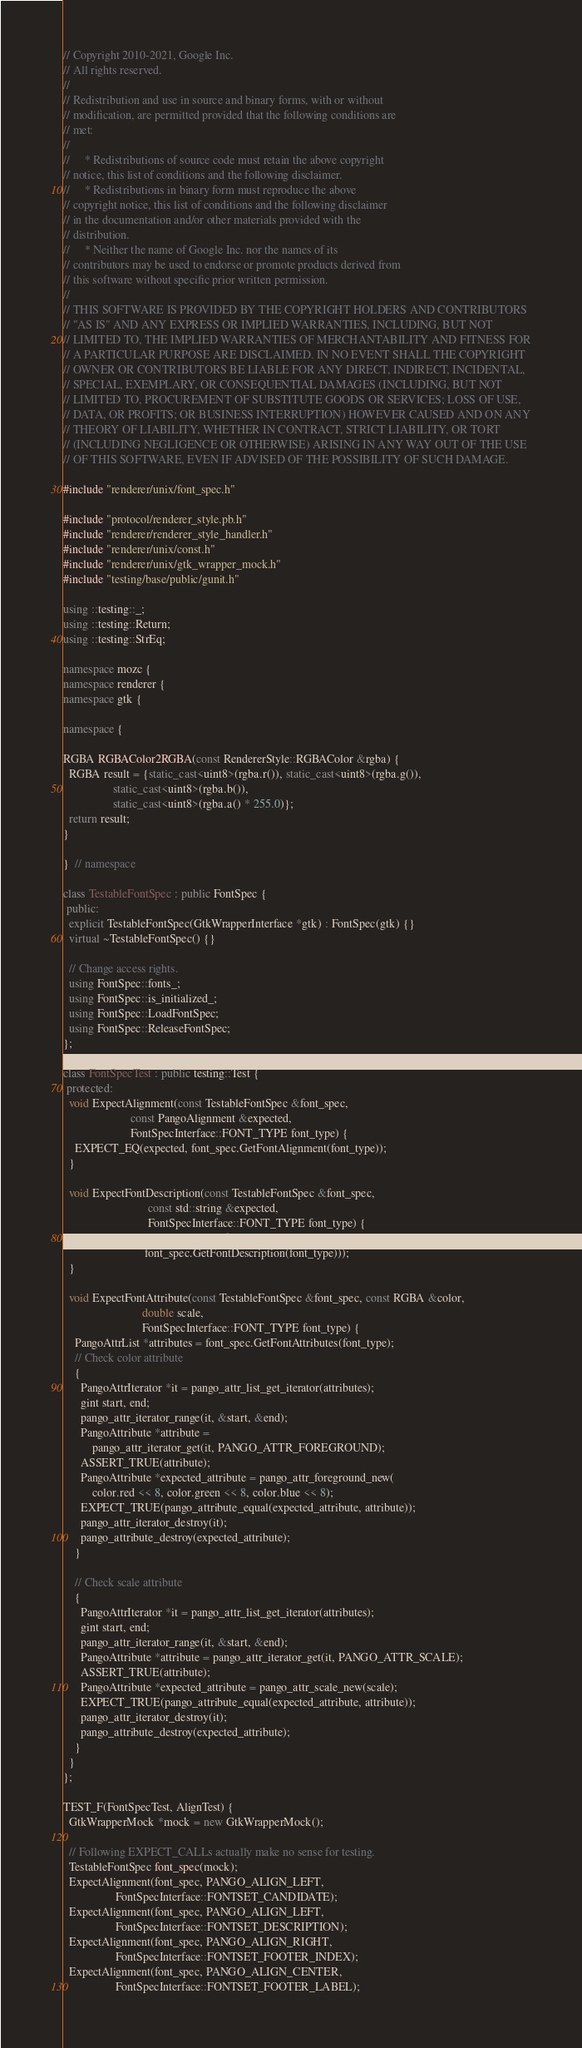Convert code to text. <code><loc_0><loc_0><loc_500><loc_500><_C++_>// Copyright 2010-2021, Google Inc.
// All rights reserved.
//
// Redistribution and use in source and binary forms, with or without
// modification, are permitted provided that the following conditions are
// met:
//
//     * Redistributions of source code must retain the above copyright
// notice, this list of conditions and the following disclaimer.
//     * Redistributions in binary form must reproduce the above
// copyright notice, this list of conditions and the following disclaimer
// in the documentation and/or other materials provided with the
// distribution.
//     * Neither the name of Google Inc. nor the names of its
// contributors may be used to endorse or promote products derived from
// this software without specific prior written permission.
//
// THIS SOFTWARE IS PROVIDED BY THE COPYRIGHT HOLDERS AND CONTRIBUTORS
// "AS IS" AND ANY EXPRESS OR IMPLIED WARRANTIES, INCLUDING, BUT NOT
// LIMITED TO, THE IMPLIED WARRANTIES OF MERCHANTABILITY AND FITNESS FOR
// A PARTICULAR PURPOSE ARE DISCLAIMED. IN NO EVENT SHALL THE COPYRIGHT
// OWNER OR CONTRIBUTORS BE LIABLE FOR ANY DIRECT, INDIRECT, INCIDENTAL,
// SPECIAL, EXEMPLARY, OR CONSEQUENTIAL DAMAGES (INCLUDING, BUT NOT
// LIMITED TO, PROCUREMENT OF SUBSTITUTE GOODS OR SERVICES; LOSS OF USE,
// DATA, OR PROFITS; OR BUSINESS INTERRUPTION) HOWEVER CAUSED AND ON ANY
// THEORY OF LIABILITY, WHETHER IN CONTRACT, STRICT LIABILITY, OR TORT
// (INCLUDING NEGLIGENCE OR OTHERWISE) ARISING IN ANY WAY OUT OF THE USE
// OF THIS SOFTWARE, EVEN IF ADVISED OF THE POSSIBILITY OF SUCH DAMAGE.

#include "renderer/unix/font_spec.h"

#include "protocol/renderer_style.pb.h"
#include "renderer/renderer_style_handler.h"
#include "renderer/unix/const.h"
#include "renderer/unix/gtk_wrapper_mock.h"
#include "testing/base/public/gunit.h"

using ::testing::_;
using ::testing::Return;
using ::testing::StrEq;

namespace mozc {
namespace renderer {
namespace gtk {

namespace {

RGBA RGBAColor2RGBA(const RendererStyle::RGBAColor &rgba) {
  RGBA result = {static_cast<uint8>(rgba.r()), static_cast<uint8>(rgba.g()),
                 static_cast<uint8>(rgba.b()),
                 static_cast<uint8>(rgba.a() * 255.0)};
  return result;
}

}  // namespace

class TestableFontSpec : public FontSpec {
 public:
  explicit TestableFontSpec(GtkWrapperInterface *gtk) : FontSpec(gtk) {}
  virtual ~TestableFontSpec() {}

  // Change access rights.
  using FontSpec::fonts_;
  using FontSpec::is_initialized_;
  using FontSpec::LoadFontSpec;
  using FontSpec::ReleaseFontSpec;
};

class FontSpecTest : public testing::Test {
 protected:
  void ExpectAlignment(const TestableFontSpec &font_spec,
                       const PangoAlignment &expected,
                       FontSpecInterface::FONT_TYPE font_type) {
    EXPECT_EQ(expected, font_spec.GetFontAlignment(font_type));
  }

  void ExpectFontDescription(const TestableFontSpec &font_spec,
                             const std::string &expected,
                             FontSpecInterface::FONT_TYPE font_type) {
    EXPECT_EQ(expected, pango_font_description_to_string(
                            font_spec.GetFontDescription(font_type)));
  }

  void ExpectFontAttribute(const TestableFontSpec &font_spec, const RGBA &color,
                           double scale,
                           FontSpecInterface::FONT_TYPE font_type) {
    PangoAttrList *attributes = font_spec.GetFontAttributes(font_type);
    // Check color attribute
    {
      PangoAttrIterator *it = pango_attr_list_get_iterator(attributes);
      gint start, end;
      pango_attr_iterator_range(it, &start, &end);
      PangoAttribute *attribute =
          pango_attr_iterator_get(it, PANGO_ATTR_FOREGROUND);
      ASSERT_TRUE(attribute);
      PangoAttribute *expected_attribute = pango_attr_foreground_new(
          color.red << 8, color.green << 8, color.blue << 8);
      EXPECT_TRUE(pango_attribute_equal(expected_attribute, attribute));
      pango_attr_iterator_destroy(it);
      pango_attribute_destroy(expected_attribute);
    }

    // Check scale attribute
    {
      PangoAttrIterator *it = pango_attr_list_get_iterator(attributes);
      gint start, end;
      pango_attr_iterator_range(it, &start, &end);
      PangoAttribute *attribute = pango_attr_iterator_get(it, PANGO_ATTR_SCALE);
      ASSERT_TRUE(attribute);
      PangoAttribute *expected_attribute = pango_attr_scale_new(scale);
      EXPECT_TRUE(pango_attribute_equal(expected_attribute, attribute));
      pango_attr_iterator_destroy(it);
      pango_attribute_destroy(expected_attribute);
    }
  }
};

TEST_F(FontSpecTest, AlignTest) {
  GtkWrapperMock *mock = new GtkWrapperMock();

  // Following EXPECT_CALLs actually make no sense for testing.
  TestableFontSpec font_spec(mock);
  ExpectAlignment(font_spec, PANGO_ALIGN_LEFT,
                  FontSpecInterface::FONTSET_CANDIDATE);
  ExpectAlignment(font_spec, PANGO_ALIGN_LEFT,
                  FontSpecInterface::FONTSET_DESCRIPTION);
  ExpectAlignment(font_spec, PANGO_ALIGN_RIGHT,
                  FontSpecInterface::FONTSET_FOOTER_INDEX);
  ExpectAlignment(font_spec, PANGO_ALIGN_CENTER,
                  FontSpecInterface::FONTSET_FOOTER_LABEL);</code> 